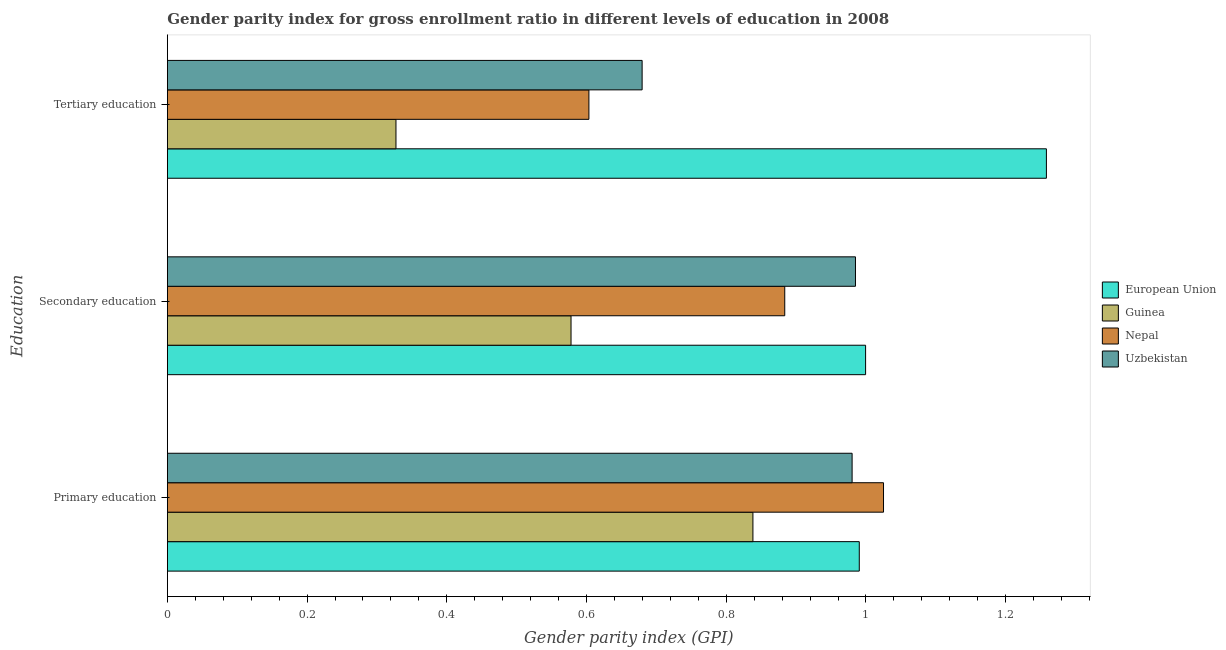Are the number of bars per tick equal to the number of legend labels?
Your answer should be very brief. Yes. Are the number of bars on each tick of the Y-axis equal?
Your answer should be compact. Yes. How many bars are there on the 2nd tick from the top?
Provide a succinct answer. 4. How many bars are there on the 2nd tick from the bottom?
Your response must be concise. 4. What is the gender parity index in primary education in Nepal?
Ensure brevity in your answer.  1.03. Across all countries, what is the maximum gender parity index in secondary education?
Provide a short and direct response. 1. Across all countries, what is the minimum gender parity index in secondary education?
Provide a succinct answer. 0.58. In which country was the gender parity index in primary education maximum?
Offer a terse response. Nepal. In which country was the gender parity index in primary education minimum?
Make the answer very short. Guinea. What is the total gender parity index in primary education in the graph?
Offer a very short reply. 3.83. What is the difference between the gender parity index in secondary education in Nepal and that in Guinea?
Your response must be concise. 0.31. What is the difference between the gender parity index in tertiary education in Guinea and the gender parity index in primary education in European Union?
Your answer should be compact. -0.66. What is the average gender parity index in primary education per country?
Offer a very short reply. 0.96. What is the difference between the gender parity index in primary education and gender parity index in tertiary education in Nepal?
Provide a short and direct response. 0.42. In how many countries, is the gender parity index in primary education greater than 1.2400000000000002 ?
Your response must be concise. 0. What is the ratio of the gender parity index in tertiary education in Nepal to that in European Union?
Offer a very short reply. 0.48. Is the gender parity index in tertiary education in European Union less than that in Uzbekistan?
Offer a terse response. No. Is the difference between the gender parity index in secondary education in Uzbekistan and Guinea greater than the difference between the gender parity index in tertiary education in Uzbekistan and Guinea?
Make the answer very short. Yes. What is the difference between the highest and the second highest gender parity index in tertiary education?
Ensure brevity in your answer.  0.58. What is the difference between the highest and the lowest gender parity index in primary education?
Keep it short and to the point. 0.19. Is the sum of the gender parity index in primary education in European Union and Guinea greater than the maximum gender parity index in secondary education across all countries?
Ensure brevity in your answer.  Yes. What does the 2nd bar from the bottom in Primary education represents?
Ensure brevity in your answer.  Guinea. Is it the case that in every country, the sum of the gender parity index in primary education and gender parity index in secondary education is greater than the gender parity index in tertiary education?
Keep it short and to the point. Yes. What is the difference between two consecutive major ticks on the X-axis?
Offer a terse response. 0.2. Are the values on the major ticks of X-axis written in scientific E-notation?
Your answer should be very brief. No. Does the graph contain any zero values?
Keep it short and to the point. No. How many legend labels are there?
Your answer should be very brief. 4. How are the legend labels stacked?
Ensure brevity in your answer.  Vertical. What is the title of the graph?
Offer a very short reply. Gender parity index for gross enrollment ratio in different levels of education in 2008. Does "Poland" appear as one of the legend labels in the graph?
Provide a succinct answer. No. What is the label or title of the X-axis?
Give a very brief answer. Gender parity index (GPI). What is the label or title of the Y-axis?
Provide a short and direct response. Education. What is the Gender parity index (GPI) of European Union in Primary education?
Your answer should be compact. 0.99. What is the Gender parity index (GPI) in Guinea in Primary education?
Offer a very short reply. 0.84. What is the Gender parity index (GPI) in Nepal in Primary education?
Offer a very short reply. 1.03. What is the Gender parity index (GPI) in Uzbekistan in Primary education?
Make the answer very short. 0.98. What is the Gender parity index (GPI) in European Union in Secondary education?
Your answer should be compact. 1. What is the Gender parity index (GPI) in Guinea in Secondary education?
Your answer should be very brief. 0.58. What is the Gender parity index (GPI) in Nepal in Secondary education?
Provide a succinct answer. 0.88. What is the Gender parity index (GPI) of Uzbekistan in Secondary education?
Make the answer very short. 0.98. What is the Gender parity index (GPI) in European Union in Tertiary education?
Ensure brevity in your answer.  1.26. What is the Gender parity index (GPI) of Guinea in Tertiary education?
Your answer should be very brief. 0.33. What is the Gender parity index (GPI) in Nepal in Tertiary education?
Make the answer very short. 0.6. What is the Gender parity index (GPI) in Uzbekistan in Tertiary education?
Keep it short and to the point. 0.68. Across all Education, what is the maximum Gender parity index (GPI) of European Union?
Give a very brief answer. 1.26. Across all Education, what is the maximum Gender parity index (GPI) in Guinea?
Ensure brevity in your answer.  0.84. Across all Education, what is the maximum Gender parity index (GPI) in Nepal?
Give a very brief answer. 1.03. Across all Education, what is the maximum Gender parity index (GPI) of Uzbekistan?
Keep it short and to the point. 0.98. Across all Education, what is the minimum Gender parity index (GPI) of European Union?
Provide a succinct answer. 0.99. Across all Education, what is the minimum Gender parity index (GPI) in Guinea?
Give a very brief answer. 0.33. Across all Education, what is the minimum Gender parity index (GPI) in Nepal?
Provide a short and direct response. 0.6. Across all Education, what is the minimum Gender parity index (GPI) of Uzbekistan?
Your response must be concise. 0.68. What is the total Gender parity index (GPI) of European Union in the graph?
Provide a succinct answer. 3.25. What is the total Gender parity index (GPI) in Guinea in the graph?
Offer a terse response. 1.74. What is the total Gender parity index (GPI) of Nepal in the graph?
Offer a very short reply. 2.51. What is the total Gender parity index (GPI) in Uzbekistan in the graph?
Ensure brevity in your answer.  2.64. What is the difference between the Gender parity index (GPI) of European Union in Primary education and that in Secondary education?
Your answer should be compact. -0.01. What is the difference between the Gender parity index (GPI) in Guinea in Primary education and that in Secondary education?
Ensure brevity in your answer.  0.26. What is the difference between the Gender parity index (GPI) in Nepal in Primary education and that in Secondary education?
Offer a terse response. 0.14. What is the difference between the Gender parity index (GPI) in Uzbekistan in Primary education and that in Secondary education?
Offer a terse response. -0. What is the difference between the Gender parity index (GPI) in European Union in Primary education and that in Tertiary education?
Your response must be concise. -0.27. What is the difference between the Gender parity index (GPI) of Guinea in Primary education and that in Tertiary education?
Offer a terse response. 0.51. What is the difference between the Gender parity index (GPI) of Nepal in Primary education and that in Tertiary education?
Provide a short and direct response. 0.42. What is the difference between the Gender parity index (GPI) of Uzbekistan in Primary education and that in Tertiary education?
Keep it short and to the point. 0.3. What is the difference between the Gender parity index (GPI) of European Union in Secondary education and that in Tertiary education?
Provide a succinct answer. -0.26. What is the difference between the Gender parity index (GPI) in Guinea in Secondary education and that in Tertiary education?
Give a very brief answer. 0.25. What is the difference between the Gender parity index (GPI) of Nepal in Secondary education and that in Tertiary education?
Provide a succinct answer. 0.28. What is the difference between the Gender parity index (GPI) of Uzbekistan in Secondary education and that in Tertiary education?
Provide a short and direct response. 0.31. What is the difference between the Gender parity index (GPI) in European Union in Primary education and the Gender parity index (GPI) in Guinea in Secondary education?
Your answer should be very brief. 0.41. What is the difference between the Gender parity index (GPI) of European Union in Primary education and the Gender parity index (GPI) of Nepal in Secondary education?
Provide a short and direct response. 0.11. What is the difference between the Gender parity index (GPI) in European Union in Primary education and the Gender parity index (GPI) in Uzbekistan in Secondary education?
Make the answer very short. 0.01. What is the difference between the Gender parity index (GPI) of Guinea in Primary education and the Gender parity index (GPI) of Nepal in Secondary education?
Give a very brief answer. -0.05. What is the difference between the Gender parity index (GPI) of Guinea in Primary education and the Gender parity index (GPI) of Uzbekistan in Secondary education?
Your answer should be very brief. -0.15. What is the difference between the Gender parity index (GPI) of Nepal in Primary education and the Gender parity index (GPI) of Uzbekistan in Secondary education?
Make the answer very short. 0.04. What is the difference between the Gender parity index (GPI) of European Union in Primary education and the Gender parity index (GPI) of Guinea in Tertiary education?
Make the answer very short. 0.66. What is the difference between the Gender parity index (GPI) of European Union in Primary education and the Gender parity index (GPI) of Nepal in Tertiary education?
Your answer should be very brief. 0.39. What is the difference between the Gender parity index (GPI) of European Union in Primary education and the Gender parity index (GPI) of Uzbekistan in Tertiary education?
Your answer should be compact. 0.31. What is the difference between the Gender parity index (GPI) in Guinea in Primary education and the Gender parity index (GPI) in Nepal in Tertiary education?
Your answer should be very brief. 0.23. What is the difference between the Gender parity index (GPI) of Guinea in Primary education and the Gender parity index (GPI) of Uzbekistan in Tertiary education?
Offer a terse response. 0.16. What is the difference between the Gender parity index (GPI) in Nepal in Primary education and the Gender parity index (GPI) in Uzbekistan in Tertiary education?
Ensure brevity in your answer.  0.35. What is the difference between the Gender parity index (GPI) in European Union in Secondary education and the Gender parity index (GPI) in Guinea in Tertiary education?
Offer a very short reply. 0.67. What is the difference between the Gender parity index (GPI) in European Union in Secondary education and the Gender parity index (GPI) in Nepal in Tertiary education?
Keep it short and to the point. 0.4. What is the difference between the Gender parity index (GPI) of European Union in Secondary education and the Gender parity index (GPI) of Uzbekistan in Tertiary education?
Make the answer very short. 0.32. What is the difference between the Gender parity index (GPI) in Guinea in Secondary education and the Gender parity index (GPI) in Nepal in Tertiary education?
Offer a very short reply. -0.03. What is the difference between the Gender parity index (GPI) in Guinea in Secondary education and the Gender parity index (GPI) in Uzbekistan in Tertiary education?
Your answer should be compact. -0.1. What is the difference between the Gender parity index (GPI) in Nepal in Secondary education and the Gender parity index (GPI) in Uzbekistan in Tertiary education?
Ensure brevity in your answer.  0.2. What is the average Gender parity index (GPI) in European Union per Education?
Your response must be concise. 1.08. What is the average Gender parity index (GPI) in Guinea per Education?
Your answer should be very brief. 0.58. What is the average Gender parity index (GPI) in Nepal per Education?
Make the answer very short. 0.84. What is the average Gender parity index (GPI) in Uzbekistan per Education?
Keep it short and to the point. 0.88. What is the difference between the Gender parity index (GPI) in European Union and Gender parity index (GPI) in Guinea in Primary education?
Your response must be concise. 0.15. What is the difference between the Gender parity index (GPI) in European Union and Gender parity index (GPI) in Nepal in Primary education?
Offer a very short reply. -0.03. What is the difference between the Gender parity index (GPI) of European Union and Gender parity index (GPI) of Uzbekistan in Primary education?
Your answer should be compact. 0.01. What is the difference between the Gender parity index (GPI) of Guinea and Gender parity index (GPI) of Nepal in Primary education?
Provide a short and direct response. -0.19. What is the difference between the Gender parity index (GPI) in Guinea and Gender parity index (GPI) in Uzbekistan in Primary education?
Provide a short and direct response. -0.14. What is the difference between the Gender parity index (GPI) in Nepal and Gender parity index (GPI) in Uzbekistan in Primary education?
Keep it short and to the point. 0.04. What is the difference between the Gender parity index (GPI) in European Union and Gender parity index (GPI) in Guinea in Secondary education?
Provide a short and direct response. 0.42. What is the difference between the Gender parity index (GPI) of European Union and Gender parity index (GPI) of Nepal in Secondary education?
Your response must be concise. 0.12. What is the difference between the Gender parity index (GPI) of European Union and Gender parity index (GPI) of Uzbekistan in Secondary education?
Your response must be concise. 0.01. What is the difference between the Gender parity index (GPI) of Guinea and Gender parity index (GPI) of Nepal in Secondary education?
Keep it short and to the point. -0.31. What is the difference between the Gender parity index (GPI) in Guinea and Gender parity index (GPI) in Uzbekistan in Secondary education?
Your response must be concise. -0.41. What is the difference between the Gender parity index (GPI) of Nepal and Gender parity index (GPI) of Uzbekistan in Secondary education?
Your response must be concise. -0.1. What is the difference between the Gender parity index (GPI) in European Union and Gender parity index (GPI) in Guinea in Tertiary education?
Offer a terse response. 0.93. What is the difference between the Gender parity index (GPI) in European Union and Gender parity index (GPI) in Nepal in Tertiary education?
Provide a short and direct response. 0.65. What is the difference between the Gender parity index (GPI) of European Union and Gender parity index (GPI) of Uzbekistan in Tertiary education?
Offer a terse response. 0.58. What is the difference between the Gender parity index (GPI) of Guinea and Gender parity index (GPI) of Nepal in Tertiary education?
Keep it short and to the point. -0.28. What is the difference between the Gender parity index (GPI) in Guinea and Gender parity index (GPI) in Uzbekistan in Tertiary education?
Offer a very short reply. -0.35. What is the difference between the Gender parity index (GPI) in Nepal and Gender parity index (GPI) in Uzbekistan in Tertiary education?
Keep it short and to the point. -0.08. What is the ratio of the Gender parity index (GPI) of European Union in Primary education to that in Secondary education?
Your response must be concise. 0.99. What is the ratio of the Gender parity index (GPI) in Guinea in Primary education to that in Secondary education?
Offer a very short reply. 1.45. What is the ratio of the Gender parity index (GPI) of Nepal in Primary education to that in Secondary education?
Offer a terse response. 1.16. What is the ratio of the Gender parity index (GPI) in Uzbekistan in Primary education to that in Secondary education?
Offer a very short reply. 1. What is the ratio of the Gender parity index (GPI) in European Union in Primary education to that in Tertiary education?
Your answer should be compact. 0.79. What is the ratio of the Gender parity index (GPI) of Guinea in Primary education to that in Tertiary education?
Your response must be concise. 2.56. What is the ratio of the Gender parity index (GPI) in Nepal in Primary education to that in Tertiary education?
Give a very brief answer. 1.7. What is the ratio of the Gender parity index (GPI) in Uzbekistan in Primary education to that in Tertiary education?
Provide a short and direct response. 1.44. What is the ratio of the Gender parity index (GPI) of European Union in Secondary education to that in Tertiary education?
Keep it short and to the point. 0.79. What is the ratio of the Gender parity index (GPI) in Guinea in Secondary education to that in Tertiary education?
Ensure brevity in your answer.  1.77. What is the ratio of the Gender parity index (GPI) of Nepal in Secondary education to that in Tertiary education?
Ensure brevity in your answer.  1.46. What is the ratio of the Gender parity index (GPI) of Uzbekistan in Secondary education to that in Tertiary education?
Keep it short and to the point. 1.45. What is the difference between the highest and the second highest Gender parity index (GPI) in European Union?
Keep it short and to the point. 0.26. What is the difference between the highest and the second highest Gender parity index (GPI) in Guinea?
Provide a short and direct response. 0.26. What is the difference between the highest and the second highest Gender parity index (GPI) of Nepal?
Offer a very short reply. 0.14. What is the difference between the highest and the second highest Gender parity index (GPI) in Uzbekistan?
Offer a terse response. 0. What is the difference between the highest and the lowest Gender parity index (GPI) in European Union?
Offer a very short reply. 0.27. What is the difference between the highest and the lowest Gender parity index (GPI) in Guinea?
Provide a short and direct response. 0.51. What is the difference between the highest and the lowest Gender parity index (GPI) in Nepal?
Give a very brief answer. 0.42. What is the difference between the highest and the lowest Gender parity index (GPI) in Uzbekistan?
Your answer should be compact. 0.31. 